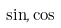<formula> <loc_0><loc_0><loc_500><loc_500>\sin , \cos</formula> 